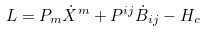Convert formula to latex. <formula><loc_0><loc_0><loc_500><loc_500>L = P _ { m } \dot { X } ^ { m } + P ^ { i j } \dot { B } _ { i j } - H _ { c }</formula> 